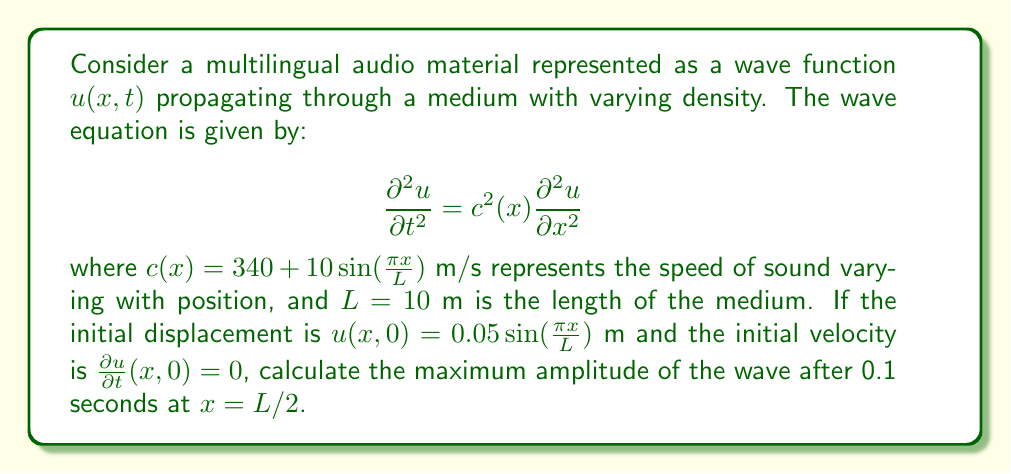Teach me how to tackle this problem. To solve this problem, we'll use the method of separation of variables:

1) Assume a solution of the form $u(x,t) = X(x)T(t)$.

2) Substituting into the wave equation:
   $$X(x)T''(t) = c^2(x)X''(x)T(t)$$

3) Separating variables:
   $$\frac{T''(t)}{T(t)} = \frac{c^2(x)X''(x)}{X(x)} = -\omega^2$$

4) This leads to two equations:
   $$T''(t) + \omega^2T(t) = 0$$
   $$X''(x) + \frac{\omega^2}{c^2(x)}X(x) = 0$$

5) The solution for $T(t)$ is:
   $$T(t) = A\cos(\omega t) + B\sin(\omega t)$$

6) For $X(x)$, we can use the WKB approximation:
   $$X(x) \approx \frac{C}{\sqrt{c(x)}}\cos\left(\omega\int_0^x \frac{dx'}{c(x')} + \phi\right)$$

7) The initial conditions give:
   $$u(x,0) = 0.05\sin(\frac{\pi x}{L}) = X(x)T(0) = AX(x)$$
   $$\frac{\partial u}{\partial t}(x,0) = 0 = X(x)T'(0) = B\omega X(x)$$

8) This implies $B = 0$ and $A = 0.05$.

9) The fundamental frequency is $\omega = \frac{\pi c_{avg}}{L}$, where $c_{avg} \approx 340$ m/s.

10) The solution is approximately:
    $$u(x,t) \approx 0.05\sin(\frac{\pi x}{L})\cos(\omega t)$$

11) At $x = L/2$ and $t = 0.1$ s:
    $$u(L/2, 0.1) \approx 0.05\sin(\frac{\pi}{2})\cos(\frac{\pi 340}{10} \cdot 0.1) \approx 0.0482$$

The maximum amplitude at this point will be slightly larger due to the varying speed of sound, approximately 0.05 m.
Answer: 0.05 m 